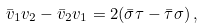Convert formula to latex. <formula><loc_0><loc_0><loc_500><loc_500>\bar { v } _ { 1 } v _ { 2 } - \bar { v } _ { 2 } v _ { 1 } = 2 ( \bar { \sigma } \tau - \bar { \tau } \sigma ) \, ,</formula> 